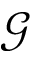Convert formula to latex. <formula><loc_0><loc_0><loc_500><loc_500>\mathcal { G }</formula> 